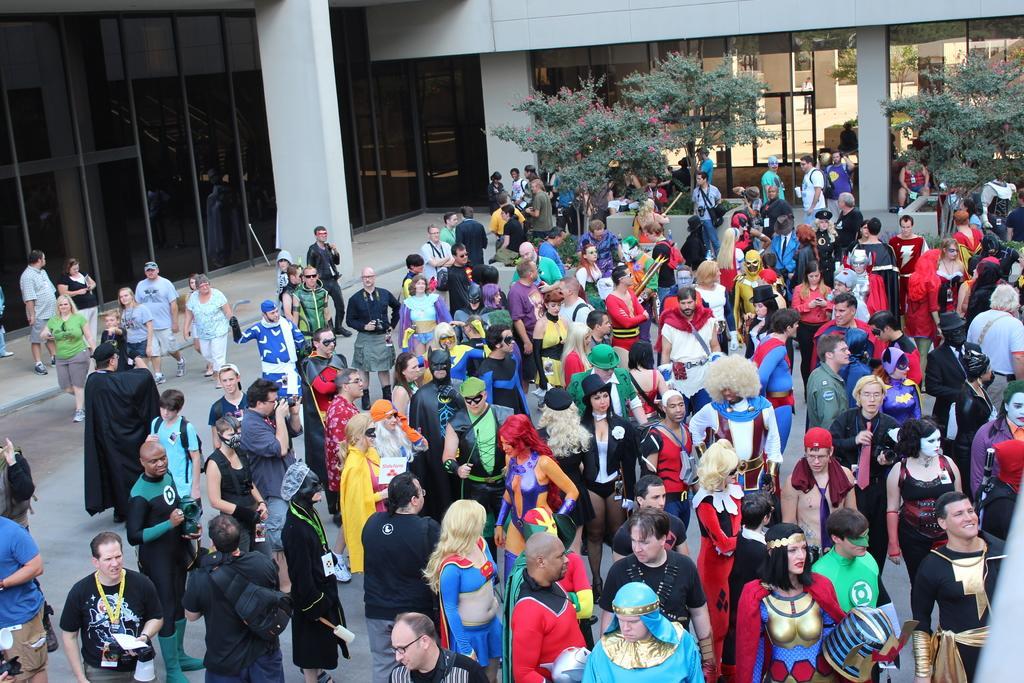How would you summarize this image in a sentence or two? In this picture we can see there are groups of people and some people are in fancy dress. Behind the people there are trees and a building. 